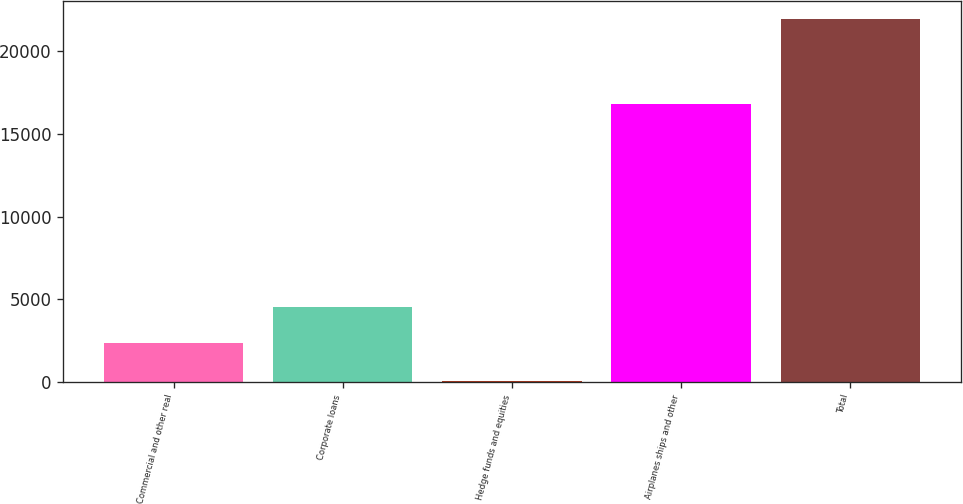Convert chart to OTSL. <chart><loc_0><loc_0><loc_500><loc_500><bar_chart><fcel>Commercial and other real<fcel>Corporate loans<fcel>Hedge funds and equities<fcel>Airplanes ships and other<fcel>Total<nl><fcel>2368<fcel>4556.9<fcel>54<fcel>16837<fcel>21943<nl></chart> 